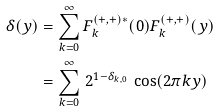<formula> <loc_0><loc_0><loc_500><loc_500>\delta ( y ) & = \sum _ { k = 0 } ^ { \infty } F ^ { ( + , + ) * } _ { k } ( 0 ) F ^ { ( + , + ) } _ { k } ( y ) \\ & = \sum _ { k = 0 } ^ { \infty } \, 2 ^ { 1 - \delta _ { k , 0 } } \, \cos ( 2 \pi k y )</formula> 